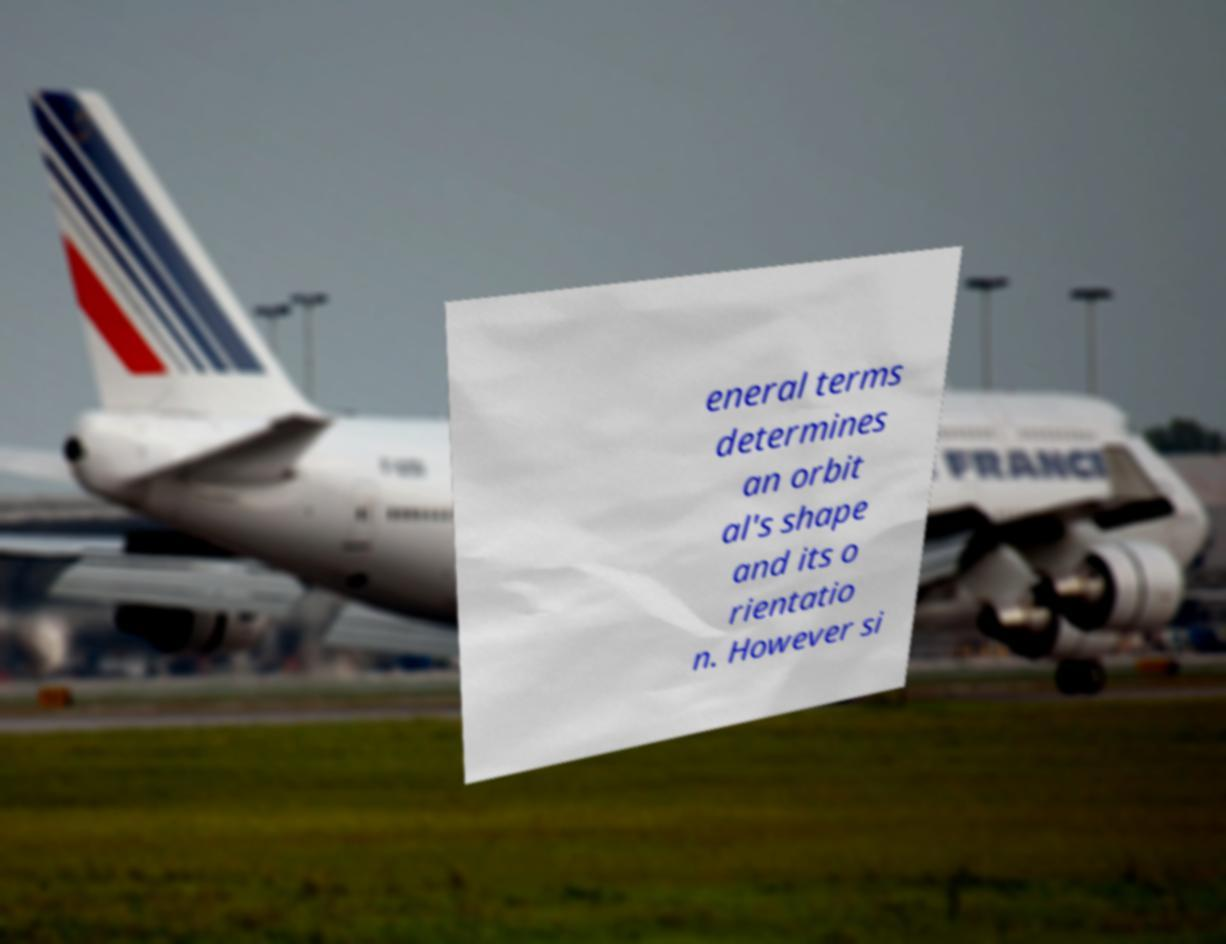I need the written content from this picture converted into text. Can you do that? eneral terms determines an orbit al's shape and its o rientatio n. However si 